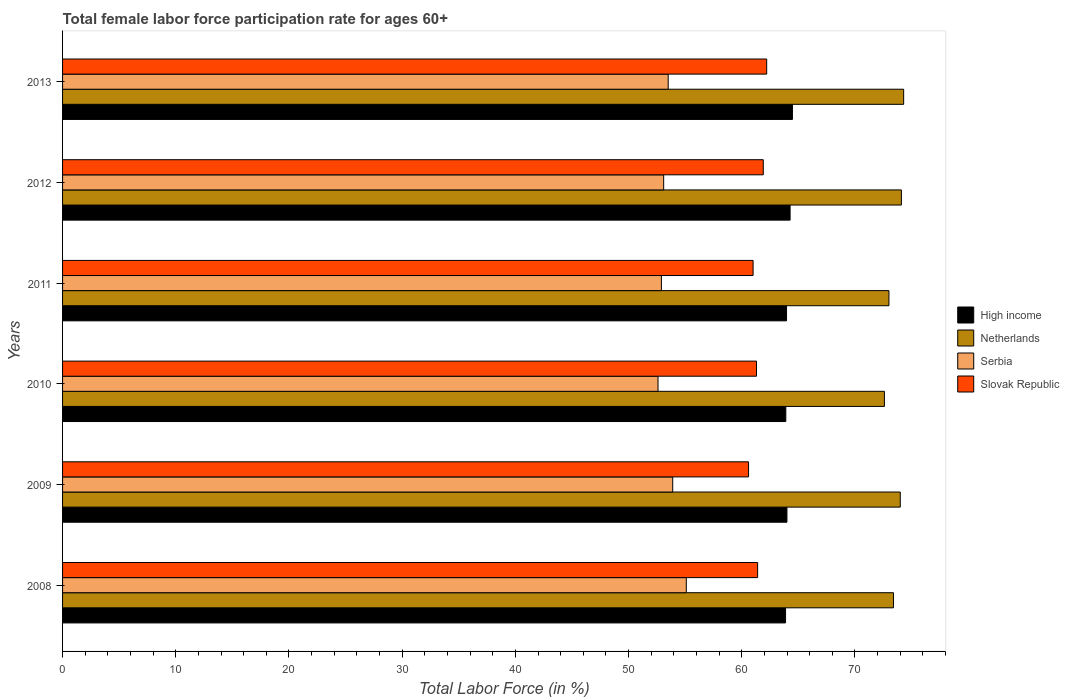What is the label of the 2nd group of bars from the top?
Provide a succinct answer. 2012. What is the female labor force participation rate in Serbia in 2013?
Your answer should be very brief. 53.5. Across all years, what is the maximum female labor force participation rate in High income?
Your response must be concise. 64.47. Across all years, what is the minimum female labor force participation rate in Netherlands?
Your answer should be very brief. 72.6. In which year was the female labor force participation rate in Serbia minimum?
Offer a very short reply. 2010. What is the total female labor force participation rate in Slovak Republic in the graph?
Keep it short and to the point. 368.4. What is the difference between the female labor force participation rate in Slovak Republic in 2008 and that in 2013?
Your answer should be very brief. -0.8. What is the difference between the female labor force participation rate in Netherlands in 2010 and the female labor force participation rate in Slovak Republic in 2008?
Your answer should be compact. 11.2. What is the average female labor force participation rate in Netherlands per year?
Provide a short and direct response. 73.57. In the year 2010, what is the difference between the female labor force participation rate in Slovak Republic and female labor force participation rate in Netherlands?
Provide a succinct answer. -11.3. What is the ratio of the female labor force participation rate in High income in 2010 to that in 2013?
Your answer should be very brief. 0.99. What is the difference between the highest and the second highest female labor force participation rate in High income?
Offer a terse response. 0.21. What is the difference between the highest and the lowest female labor force participation rate in Netherlands?
Ensure brevity in your answer.  1.7. In how many years, is the female labor force participation rate in Slovak Republic greater than the average female labor force participation rate in Slovak Republic taken over all years?
Give a very brief answer. 3. Is it the case that in every year, the sum of the female labor force participation rate in High income and female labor force participation rate in Serbia is greater than the sum of female labor force participation rate in Netherlands and female labor force participation rate in Slovak Republic?
Keep it short and to the point. No. What does the 2nd bar from the top in 2012 represents?
Your response must be concise. Serbia. How many bars are there?
Provide a succinct answer. 24. Are all the bars in the graph horizontal?
Your answer should be very brief. Yes. How many years are there in the graph?
Provide a succinct answer. 6. Are the values on the major ticks of X-axis written in scientific E-notation?
Give a very brief answer. No. Does the graph contain any zero values?
Ensure brevity in your answer.  No. Does the graph contain grids?
Your answer should be very brief. No. Where does the legend appear in the graph?
Your answer should be compact. Center right. How many legend labels are there?
Provide a succinct answer. 4. How are the legend labels stacked?
Provide a succinct answer. Vertical. What is the title of the graph?
Provide a short and direct response. Total female labor force participation rate for ages 60+. Does "Aruba" appear as one of the legend labels in the graph?
Provide a short and direct response. No. What is the label or title of the X-axis?
Give a very brief answer. Total Labor Force (in %). What is the Total Labor Force (in %) in High income in 2008?
Offer a terse response. 63.87. What is the Total Labor Force (in %) of Netherlands in 2008?
Provide a short and direct response. 73.4. What is the Total Labor Force (in %) of Serbia in 2008?
Your response must be concise. 55.1. What is the Total Labor Force (in %) in Slovak Republic in 2008?
Provide a succinct answer. 61.4. What is the Total Labor Force (in %) of High income in 2009?
Your answer should be compact. 63.99. What is the Total Labor Force (in %) of Serbia in 2009?
Give a very brief answer. 53.9. What is the Total Labor Force (in %) of Slovak Republic in 2009?
Your answer should be compact. 60.6. What is the Total Labor Force (in %) of High income in 2010?
Ensure brevity in your answer.  63.89. What is the Total Labor Force (in %) of Netherlands in 2010?
Keep it short and to the point. 72.6. What is the Total Labor Force (in %) of Serbia in 2010?
Your answer should be very brief. 52.6. What is the Total Labor Force (in %) of Slovak Republic in 2010?
Keep it short and to the point. 61.3. What is the Total Labor Force (in %) of High income in 2011?
Provide a short and direct response. 63.95. What is the Total Labor Force (in %) of Serbia in 2011?
Provide a succinct answer. 52.9. What is the Total Labor Force (in %) of Slovak Republic in 2011?
Offer a terse response. 61. What is the Total Labor Force (in %) in High income in 2012?
Your answer should be compact. 64.27. What is the Total Labor Force (in %) in Netherlands in 2012?
Provide a short and direct response. 74.1. What is the Total Labor Force (in %) in Serbia in 2012?
Your answer should be compact. 53.1. What is the Total Labor Force (in %) in Slovak Republic in 2012?
Keep it short and to the point. 61.9. What is the Total Labor Force (in %) in High income in 2013?
Offer a terse response. 64.47. What is the Total Labor Force (in %) of Netherlands in 2013?
Offer a very short reply. 74.3. What is the Total Labor Force (in %) in Serbia in 2013?
Ensure brevity in your answer.  53.5. What is the Total Labor Force (in %) of Slovak Republic in 2013?
Your answer should be compact. 62.2. Across all years, what is the maximum Total Labor Force (in %) in High income?
Offer a very short reply. 64.47. Across all years, what is the maximum Total Labor Force (in %) of Netherlands?
Your answer should be compact. 74.3. Across all years, what is the maximum Total Labor Force (in %) in Serbia?
Offer a very short reply. 55.1. Across all years, what is the maximum Total Labor Force (in %) in Slovak Republic?
Your answer should be compact. 62.2. Across all years, what is the minimum Total Labor Force (in %) in High income?
Offer a terse response. 63.87. Across all years, what is the minimum Total Labor Force (in %) of Netherlands?
Your answer should be very brief. 72.6. Across all years, what is the minimum Total Labor Force (in %) in Serbia?
Provide a succinct answer. 52.6. Across all years, what is the minimum Total Labor Force (in %) of Slovak Republic?
Provide a short and direct response. 60.6. What is the total Total Labor Force (in %) of High income in the graph?
Offer a very short reply. 384.44. What is the total Total Labor Force (in %) in Netherlands in the graph?
Give a very brief answer. 441.4. What is the total Total Labor Force (in %) of Serbia in the graph?
Your answer should be very brief. 321.1. What is the total Total Labor Force (in %) of Slovak Republic in the graph?
Keep it short and to the point. 368.4. What is the difference between the Total Labor Force (in %) in High income in 2008 and that in 2009?
Keep it short and to the point. -0.12. What is the difference between the Total Labor Force (in %) of Netherlands in 2008 and that in 2009?
Keep it short and to the point. -0.6. What is the difference between the Total Labor Force (in %) in High income in 2008 and that in 2010?
Provide a succinct answer. -0.02. What is the difference between the Total Labor Force (in %) of Serbia in 2008 and that in 2010?
Provide a short and direct response. 2.5. What is the difference between the Total Labor Force (in %) in High income in 2008 and that in 2011?
Keep it short and to the point. -0.09. What is the difference between the Total Labor Force (in %) in Netherlands in 2008 and that in 2011?
Your answer should be compact. 0.4. What is the difference between the Total Labor Force (in %) in Serbia in 2008 and that in 2011?
Make the answer very short. 2.2. What is the difference between the Total Labor Force (in %) in Slovak Republic in 2008 and that in 2011?
Your answer should be compact. 0.4. What is the difference between the Total Labor Force (in %) in High income in 2008 and that in 2012?
Keep it short and to the point. -0.4. What is the difference between the Total Labor Force (in %) in Serbia in 2008 and that in 2012?
Make the answer very short. 2. What is the difference between the Total Labor Force (in %) in Slovak Republic in 2008 and that in 2012?
Provide a short and direct response. -0.5. What is the difference between the Total Labor Force (in %) in High income in 2008 and that in 2013?
Your answer should be very brief. -0.61. What is the difference between the Total Labor Force (in %) of Netherlands in 2008 and that in 2013?
Provide a succinct answer. -0.9. What is the difference between the Total Labor Force (in %) of Slovak Republic in 2008 and that in 2013?
Ensure brevity in your answer.  -0.8. What is the difference between the Total Labor Force (in %) in High income in 2009 and that in 2010?
Provide a succinct answer. 0.1. What is the difference between the Total Labor Force (in %) of Netherlands in 2009 and that in 2010?
Give a very brief answer. 1.4. What is the difference between the Total Labor Force (in %) in High income in 2009 and that in 2011?
Ensure brevity in your answer.  0.04. What is the difference between the Total Labor Force (in %) in Netherlands in 2009 and that in 2011?
Provide a succinct answer. 1. What is the difference between the Total Labor Force (in %) in Serbia in 2009 and that in 2011?
Your response must be concise. 1. What is the difference between the Total Labor Force (in %) in Slovak Republic in 2009 and that in 2011?
Ensure brevity in your answer.  -0.4. What is the difference between the Total Labor Force (in %) in High income in 2009 and that in 2012?
Offer a very short reply. -0.28. What is the difference between the Total Labor Force (in %) in Slovak Republic in 2009 and that in 2012?
Your answer should be compact. -1.3. What is the difference between the Total Labor Force (in %) in High income in 2009 and that in 2013?
Give a very brief answer. -0.49. What is the difference between the Total Labor Force (in %) of Slovak Republic in 2009 and that in 2013?
Offer a terse response. -1.6. What is the difference between the Total Labor Force (in %) of High income in 2010 and that in 2011?
Your response must be concise. -0.06. What is the difference between the Total Labor Force (in %) of Serbia in 2010 and that in 2011?
Offer a very short reply. -0.3. What is the difference between the Total Labor Force (in %) of High income in 2010 and that in 2012?
Provide a short and direct response. -0.38. What is the difference between the Total Labor Force (in %) of Serbia in 2010 and that in 2012?
Offer a very short reply. -0.5. What is the difference between the Total Labor Force (in %) in High income in 2010 and that in 2013?
Keep it short and to the point. -0.58. What is the difference between the Total Labor Force (in %) in Netherlands in 2010 and that in 2013?
Offer a very short reply. -1.7. What is the difference between the Total Labor Force (in %) in Slovak Republic in 2010 and that in 2013?
Keep it short and to the point. -0.9. What is the difference between the Total Labor Force (in %) in High income in 2011 and that in 2012?
Your answer should be very brief. -0.31. What is the difference between the Total Labor Force (in %) in Netherlands in 2011 and that in 2012?
Provide a succinct answer. -1.1. What is the difference between the Total Labor Force (in %) in Slovak Republic in 2011 and that in 2012?
Provide a succinct answer. -0.9. What is the difference between the Total Labor Force (in %) of High income in 2011 and that in 2013?
Your answer should be compact. -0.52. What is the difference between the Total Labor Force (in %) in Netherlands in 2011 and that in 2013?
Keep it short and to the point. -1.3. What is the difference between the Total Labor Force (in %) of High income in 2012 and that in 2013?
Offer a very short reply. -0.21. What is the difference between the Total Labor Force (in %) in Netherlands in 2012 and that in 2013?
Your answer should be very brief. -0.2. What is the difference between the Total Labor Force (in %) in Slovak Republic in 2012 and that in 2013?
Your answer should be very brief. -0.3. What is the difference between the Total Labor Force (in %) in High income in 2008 and the Total Labor Force (in %) in Netherlands in 2009?
Your answer should be compact. -10.13. What is the difference between the Total Labor Force (in %) in High income in 2008 and the Total Labor Force (in %) in Serbia in 2009?
Your answer should be very brief. 9.97. What is the difference between the Total Labor Force (in %) in High income in 2008 and the Total Labor Force (in %) in Slovak Republic in 2009?
Offer a terse response. 3.27. What is the difference between the Total Labor Force (in %) in Netherlands in 2008 and the Total Labor Force (in %) in Serbia in 2009?
Offer a terse response. 19.5. What is the difference between the Total Labor Force (in %) of High income in 2008 and the Total Labor Force (in %) of Netherlands in 2010?
Make the answer very short. -8.73. What is the difference between the Total Labor Force (in %) of High income in 2008 and the Total Labor Force (in %) of Serbia in 2010?
Your answer should be very brief. 11.27. What is the difference between the Total Labor Force (in %) in High income in 2008 and the Total Labor Force (in %) in Slovak Republic in 2010?
Your response must be concise. 2.57. What is the difference between the Total Labor Force (in %) in Netherlands in 2008 and the Total Labor Force (in %) in Serbia in 2010?
Make the answer very short. 20.8. What is the difference between the Total Labor Force (in %) of High income in 2008 and the Total Labor Force (in %) of Netherlands in 2011?
Make the answer very short. -9.13. What is the difference between the Total Labor Force (in %) of High income in 2008 and the Total Labor Force (in %) of Serbia in 2011?
Give a very brief answer. 10.97. What is the difference between the Total Labor Force (in %) in High income in 2008 and the Total Labor Force (in %) in Slovak Republic in 2011?
Provide a short and direct response. 2.87. What is the difference between the Total Labor Force (in %) in Netherlands in 2008 and the Total Labor Force (in %) in Serbia in 2011?
Your response must be concise. 20.5. What is the difference between the Total Labor Force (in %) in Netherlands in 2008 and the Total Labor Force (in %) in Slovak Republic in 2011?
Your answer should be compact. 12.4. What is the difference between the Total Labor Force (in %) of High income in 2008 and the Total Labor Force (in %) of Netherlands in 2012?
Ensure brevity in your answer.  -10.23. What is the difference between the Total Labor Force (in %) of High income in 2008 and the Total Labor Force (in %) of Serbia in 2012?
Your answer should be very brief. 10.77. What is the difference between the Total Labor Force (in %) in High income in 2008 and the Total Labor Force (in %) in Slovak Republic in 2012?
Give a very brief answer. 1.97. What is the difference between the Total Labor Force (in %) in Netherlands in 2008 and the Total Labor Force (in %) in Serbia in 2012?
Give a very brief answer. 20.3. What is the difference between the Total Labor Force (in %) of High income in 2008 and the Total Labor Force (in %) of Netherlands in 2013?
Offer a very short reply. -10.43. What is the difference between the Total Labor Force (in %) in High income in 2008 and the Total Labor Force (in %) in Serbia in 2013?
Your response must be concise. 10.37. What is the difference between the Total Labor Force (in %) of High income in 2008 and the Total Labor Force (in %) of Slovak Republic in 2013?
Keep it short and to the point. 1.67. What is the difference between the Total Labor Force (in %) of Netherlands in 2008 and the Total Labor Force (in %) of Slovak Republic in 2013?
Provide a short and direct response. 11.2. What is the difference between the Total Labor Force (in %) in High income in 2009 and the Total Labor Force (in %) in Netherlands in 2010?
Your response must be concise. -8.61. What is the difference between the Total Labor Force (in %) in High income in 2009 and the Total Labor Force (in %) in Serbia in 2010?
Your answer should be very brief. 11.39. What is the difference between the Total Labor Force (in %) of High income in 2009 and the Total Labor Force (in %) of Slovak Republic in 2010?
Offer a terse response. 2.69. What is the difference between the Total Labor Force (in %) of Netherlands in 2009 and the Total Labor Force (in %) of Serbia in 2010?
Keep it short and to the point. 21.4. What is the difference between the Total Labor Force (in %) in Netherlands in 2009 and the Total Labor Force (in %) in Slovak Republic in 2010?
Your answer should be compact. 12.7. What is the difference between the Total Labor Force (in %) of Serbia in 2009 and the Total Labor Force (in %) of Slovak Republic in 2010?
Make the answer very short. -7.4. What is the difference between the Total Labor Force (in %) in High income in 2009 and the Total Labor Force (in %) in Netherlands in 2011?
Give a very brief answer. -9.01. What is the difference between the Total Labor Force (in %) in High income in 2009 and the Total Labor Force (in %) in Serbia in 2011?
Ensure brevity in your answer.  11.09. What is the difference between the Total Labor Force (in %) of High income in 2009 and the Total Labor Force (in %) of Slovak Republic in 2011?
Provide a succinct answer. 2.99. What is the difference between the Total Labor Force (in %) in Netherlands in 2009 and the Total Labor Force (in %) in Serbia in 2011?
Your answer should be very brief. 21.1. What is the difference between the Total Labor Force (in %) of Netherlands in 2009 and the Total Labor Force (in %) of Slovak Republic in 2011?
Your response must be concise. 13. What is the difference between the Total Labor Force (in %) in Serbia in 2009 and the Total Labor Force (in %) in Slovak Republic in 2011?
Ensure brevity in your answer.  -7.1. What is the difference between the Total Labor Force (in %) of High income in 2009 and the Total Labor Force (in %) of Netherlands in 2012?
Provide a short and direct response. -10.11. What is the difference between the Total Labor Force (in %) of High income in 2009 and the Total Labor Force (in %) of Serbia in 2012?
Make the answer very short. 10.89. What is the difference between the Total Labor Force (in %) of High income in 2009 and the Total Labor Force (in %) of Slovak Republic in 2012?
Offer a very short reply. 2.09. What is the difference between the Total Labor Force (in %) of Netherlands in 2009 and the Total Labor Force (in %) of Serbia in 2012?
Give a very brief answer. 20.9. What is the difference between the Total Labor Force (in %) in Netherlands in 2009 and the Total Labor Force (in %) in Slovak Republic in 2012?
Your answer should be very brief. 12.1. What is the difference between the Total Labor Force (in %) of Serbia in 2009 and the Total Labor Force (in %) of Slovak Republic in 2012?
Provide a succinct answer. -8. What is the difference between the Total Labor Force (in %) in High income in 2009 and the Total Labor Force (in %) in Netherlands in 2013?
Ensure brevity in your answer.  -10.31. What is the difference between the Total Labor Force (in %) in High income in 2009 and the Total Labor Force (in %) in Serbia in 2013?
Offer a very short reply. 10.49. What is the difference between the Total Labor Force (in %) in High income in 2009 and the Total Labor Force (in %) in Slovak Republic in 2013?
Give a very brief answer. 1.79. What is the difference between the Total Labor Force (in %) of Netherlands in 2009 and the Total Labor Force (in %) of Serbia in 2013?
Ensure brevity in your answer.  20.5. What is the difference between the Total Labor Force (in %) of Serbia in 2009 and the Total Labor Force (in %) of Slovak Republic in 2013?
Provide a succinct answer. -8.3. What is the difference between the Total Labor Force (in %) in High income in 2010 and the Total Labor Force (in %) in Netherlands in 2011?
Your response must be concise. -9.11. What is the difference between the Total Labor Force (in %) of High income in 2010 and the Total Labor Force (in %) of Serbia in 2011?
Your answer should be very brief. 10.99. What is the difference between the Total Labor Force (in %) of High income in 2010 and the Total Labor Force (in %) of Slovak Republic in 2011?
Ensure brevity in your answer.  2.89. What is the difference between the Total Labor Force (in %) in Netherlands in 2010 and the Total Labor Force (in %) in Slovak Republic in 2011?
Make the answer very short. 11.6. What is the difference between the Total Labor Force (in %) in High income in 2010 and the Total Labor Force (in %) in Netherlands in 2012?
Your response must be concise. -10.21. What is the difference between the Total Labor Force (in %) of High income in 2010 and the Total Labor Force (in %) of Serbia in 2012?
Offer a terse response. 10.79. What is the difference between the Total Labor Force (in %) in High income in 2010 and the Total Labor Force (in %) in Slovak Republic in 2012?
Make the answer very short. 1.99. What is the difference between the Total Labor Force (in %) of Netherlands in 2010 and the Total Labor Force (in %) of Slovak Republic in 2012?
Keep it short and to the point. 10.7. What is the difference between the Total Labor Force (in %) of Serbia in 2010 and the Total Labor Force (in %) of Slovak Republic in 2012?
Ensure brevity in your answer.  -9.3. What is the difference between the Total Labor Force (in %) of High income in 2010 and the Total Labor Force (in %) of Netherlands in 2013?
Give a very brief answer. -10.41. What is the difference between the Total Labor Force (in %) in High income in 2010 and the Total Labor Force (in %) in Serbia in 2013?
Make the answer very short. 10.39. What is the difference between the Total Labor Force (in %) of High income in 2010 and the Total Labor Force (in %) of Slovak Republic in 2013?
Offer a terse response. 1.69. What is the difference between the Total Labor Force (in %) of Netherlands in 2010 and the Total Labor Force (in %) of Slovak Republic in 2013?
Your answer should be compact. 10.4. What is the difference between the Total Labor Force (in %) of Serbia in 2010 and the Total Labor Force (in %) of Slovak Republic in 2013?
Offer a terse response. -9.6. What is the difference between the Total Labor Force (in %) in High income in 2011 and the Total Labor Force (in %) in Netherlands in 2012?
Ensure brevity in your answer.  -10.15. What is the difference between the Total Labor Force (in %) of High income in 2011 and the Total Labor Force (in %) of Serbia in 2012?
Offer a very short reply. 10.85. What is the difference between the Total Labor Force (in %) of High income in 2011 and the Total Labor Force (in %) of Slovak Republic in 2012?
Make the answer very short. 2.05. What is the difference between the Total Labor Force (in %) in Serbia in 2011 and the Total Labor Force (in %) in Slovak Republic in 2012?
Your answer should be compact. -9. What is the difference between the Total Labor Force (in %) in High income in 2011 and the Total Labor Force (in %) in Netherlands in 2013?
Give a very brief answer. -10.35. What is the difference between the Total Labor Force (in %) of High income in 2011 and the Total Labor Force (in %) of Serbia in 2013?
Your response must be concise. 10.45. What is the difference between the Total Labor Force (in %) in High income in 2011 and the Total Labor Force (in %) in Slovak Republic in 2013?
Keep it short and to the point. 1.75. What is the difference between the Total Labor Force (in %) of Netherlands in 2011 and the Total Labor Force (in %) of Slovak Republic in 2013?
Offer a very short reply. 10.8. What is the difference between the Total Labor Force (in %) in High income in 2012 and the Total Labor Force (in %) in Netherlands in 2013?
Your answer should be very brief. -10.03. What is the difference between the Total Labor Force (in %) of High income in 2012 and the Total Labor Force (in %) of Serbia in 2013?
Keep it short and to the point. 10.77. What is the difference between the Total Labor Force (in %) in High income in 2012 and the Total Labor Force (in %) in Slovak Republic in 2013?
Offer a very short reply. 2.07. What is the difference between the Total Labor Force (in %) in Netherlands in 2012 and the Total Labor Force (in %) in Serbia in 2013?
Offer a very short reply. 20.6. What is the difference between the Total Labor Force (in %) of Netherlands in 2012 and the Total Labor Force (in %) of Slovak Republic in 2013?
Offer a very short reply. 11.9. What is the average Total Labor Force (in %) of High income per year?
Offer a terse response. 64.07. What is the average Total Labor Force (in %) of Netherlands per year?
Offer a terse response. 73.57. What is the average Total Labor Force (in %) of Serbia per year?
Your response must be concise. 53.52. What is the average Total Labor Force (in %) in Slovak Republic per year?
Keep it short and to the point. 61.4. In the year 2008, what is the difference between the Total Labor Force (in %) in High income and Total Labor Force (in %) in Netherlands?
Your response must be concise. -9.53. In the year 2008, what is the difference between the Total Labor Force (in %) of High income and Total Labor Force (in %) of Serbia?
Make the answer very short. 8.77. In the year 2008, what is the difference between the Total Labor Force (in %) in High income and Total Labor Force (in %) in Slovak Republic?
Provide a short and direct response. 2.47. In the year 2008, what is the difference between the Total Labor Force (in %) of Serbia and Total Labor Force (in %) of Slovak Republic?
Ensure brevity in your answer.  -6.3. In the year 2009, what is the difference between the Total Labor Force (in %) of High income and Total Labor Force (in %) of Netherlands?
Your response must be concise. -10.01. In the year 2009, what is the difference between the Total Labor Force (in %) in High income and Total Labor Force (in %) in Serbia?
Your response must be concise. 10.09. In the year 2009, what is the difference between the Total Labor Force (in %) of High income and Total Labor Force (in %) of Slovak Republic?
Offer a terse response. 3.39. In the year 2009, what is the difference between the Total Labor Force (in %) of Netherlands and Total Labor Force (in %) of Serbia?
Your answer should be very brief. 20.1. In the year 2009, what is the difference between the Total Labor Force (in %) in Netherlands and Total Labor Force (in %) in Slovak Republic?
Ensure brevity in your answer.  13.4. In the year 2010, what is the difference between the Total Labor Force (in %) of High income and Total Labor Force (in %) of Netherlands?
Offer a terse response. -8.71. In the year 2010, what is the difference between the Total Labor Force (in %) in High income and Total Labor Force (in %) in Serbia?
Your answer should be compact. 11.29. In the year 2010, what is the difference between the Total Labor Force (in %) of High income and Total Labor Force (in %) of Slovak Republic?
Your answer should be very brief. 2.59. In the year 2010, what is the difference between the Total Labor Force (in %) of Netherlands and Total Labor Force (in %) of Slovak Republic?
Ensure brevity in your answer.  11.3. In the year 2010, what is the difference between the Total Labor Force (in %) of Serbia and Total Labor Force (in %) of Slovak Republic?
Your answer should be compact. -8.7. In the year 2011, what is the difference between the Total Labor Force (in %) in High income and Total Labor Force (in %) in Netherlands?
Offer a terse response. -9.05. In the year 2011, what is the difference between the Total Labor Force (in %) in High income and Total Labor Force (in %) in Serbia?
Your answer should be very brief. 11.05. In the year 2011, what is the difference between the Total Labor Force (in %) in High income and Total Labor Force (in %) in Slovak Republic?
Offer a very short reply. 2.95. In the year 2011, what is the difference between the Total Labor Force (in %) of Netherlands and Total Labor Force (in %) of Serbia?
Your answer should be compact. 20.1. In the year 2011, what is the difference between the Total Labor Force (in %) of Netherlands and Total Labor Force (in %) of Slovak Republic?
Your answer should be very brief. 12. In the year 2012, what is the difference between the Total Labor Force (in %) of High income and Total Labor Force (in %) of Netherlands?
Offer a terse response. -9.83. In the year 2012, what is the difference between the Total Labor Force (in %) in High income and Total Labor Force (in %) in Serbia?
Give a very brief answer. 11.17. In the year 2012, what is the difference between the Total Labor Force (in %) in High income and Total Labor Force (in %) in Slovak Republic?
Provide a succinct answer. 2.37. In the year 2012, what is the difference between the Total Labor Force (in %) of Netherlands and Total Labor Force (in %) of Slovak Republic?
Provide a succinct answer. 12.2. In the year 2012, what is the difference between the Total Labor Force (in %) in Serbia and Total Labor Force (in %) in Slovak Republic?
Your answer should be very brief. -8.8. In the year 2013, what is the difference between the Total Labor Force (in %) in High income and Total Labor Force (in %) in Netherlands?
Provide a succinct answer. -9.83. In the year 2013, what is the difference between the Total Labor Force (in %) of High income and Total Labor Force (in %) of Serbia?
Offer a very short reply. 10.97. In the year 2013, what is the difference between the Total Labor Force (in %) of High income and Total Labor Force (in %) of Slovak Republic?
Give a very brief answer. 2.27. In the year 2013, what is the difference between the Total Labor Force (in %) in Netherlands and Total Labor Force (in %) in Serbia?
Your response must be concise. 20.8. What is the ratio of the Total Labor Force (in %) of High income in 2008 to that in 2009?
Make the answer very short. 1. What is the ratio of the Total Labor Force (in %) in Serbia in 2008 to that in 2009?
Your response must be concise. 1.02. What is the ratio of the Total Labor Force (in %) in Slovak Republic in 2008 to that in 2009?
Your response must be concise. 1.01. What is the ratio of the Total Labor Force (in %) in High income in 2008 to that in 2010?
Ensure brevity in your answer.  1. What is the ratio of the Total Labor Force (in %) of Netherlands in 2008 to that in 2010?
Your answer should be very brief. 1.01. What is the ratio of the Total Labor Force (in %) in Serbia in 2008 to that in 2010?
Provide a succinct answer. 1.05. What is the ratio of the Total Labor Force (in %) in Slovak Republic in 2008 to that in 2010?
Offer a terse response. 1. What is the ratio of the Total Labor Force (in %) in Netherlands in 2008 to that in 2011?
Provide a short and direct response. 1.01. What is the ratio of the Total Labor Force (in %) in Serbia in 2008 to that in 2011?
Make the answer very short. 1.04. What is the ratio of the Total Labor Force (in %) of Slovak Republic in 2008 to that in 2011?
Offer a terse response. 1.01. What is the ratio of the Total Labor Force (in %) in High income in 2008 to that in 2012?
Your answer should be very brief. 0.99. What is the ratio of the Total Labor Force (in %) of Netherlands in 2008 to that in 2012?
Offer a terse response. 0.99. What is the ratio of the Total Labor Force (in %) of Serbia in 2008 to that in 2012?
Provide a succinct answer. 1.04. What is the ratio of the Total Labor Force (in %) of Slovak Republic in 2008 to that in 2012?
Offer a terse response. 0.99. What is the ratio of the Total Labor Force (in %) of High income in 2008 to that in 2013?
Give a very brief answer. 0.99. What is the ratio of the Total Labor Force (in %) of Netherlands in 2008 to that in 2013?
Offer a terse response. 0.99. What is the ratio of the Total Labor Force (in %) in Serbia in 2008 to that in 2013?
Offer a very short reply. 1.03. What is the ratio of the Total Labor Force (in %) of Slovak Republic in 2008 to that in 2013?
Make the answer very short. 0.99. What is the ratio of the Total Labor Force (in %) of Netherlands in 2009 to that in 2010?
Offer a terse response. 1.02. What is the ratio of the Total Labor Force (in %) in Serbia in 2009 to that in 2010?
Provide a succinct answer. 1.02. What is the ratio of the Total Labor Force (in %) of Netherlands in 2009 to that in 2011?
Provide a succinct answer. 1.01. What is the ratio of the Total Labor Force (in %) in Serbia in 2009 to that in 2011?
Offer a terse response. 1.02. What is the ratio of the Total Labor Force (in %) of High income in 2009 to that in 2012?
Give a very brief answer. 1. What is the ratio of the Total Labor Force (in %) of Netherlands in 2009 to that in 2012?
Keep it short and to the point. 1. What is the ratio of the Total Labor Force (in %) in Serbia in 2009 to that in 2012?
Offer a terse response. 1.02. What is the ratio of the Total Labor Force (in %) of High income in 2009 to that in 2013?
Provide a succinct answer. 0.99. What is the ratio of the Total Labor Force (in %) in Serbia in 2009 to that in 2013?
Ensure brevity in your answer.  1.01. What is the ratio of the Total Labor Force (in %) of Slovak Republic in 2009 to that in 2013?
Your answer should be very brief. 0.97. What is the ratio of the Total Labor Force (in %) of High income in 2010 to that in 2011?
Your answer should be very brief. 1. What is the ratio of the Total Labor Force (in %) of Netherlands in 2010 to that in 2011?
Offer a terse response. 0.99. What is the ratio of the Total Labor Force (in %) in Serbia in 2010 to that in 2011?
Keep it short and to the point. 0.99. What is the ratio of the Total Labor Force (in %) in Slovak Republic in 2010 to that in 2011?
Provide a succinct answer. 1. What is the ratio of the Total Labor Force (in %) in Netherlands in 2010 to that in 2012?
Offer a very short reply. 0.98. What is the ratio of the Total Labor Force (in %) of Serbia in 2010 to that in 2012?
Give a very brief answer. 0.99. What is the ratio of the Total Labor Force (in %) in Slovak Republic in 2010 to that in 2012?
Give a very brief answer. 0.99. What is the ratio of the Total Labor Force (in %) of High income in 2010 to that in 2013?
Provide a short and direct response. 0.99. What is the ratio of the Total Labor Force (in %) in Netherlands in 2010 to that in 2013?
Ensure brevity in your answer.  0.98. What is the ratio of the Total Labor Force (in %) in Serbia in 2010 to that in 2013?
Your answer should be very brief. 0.98. What is the ratio of the Total Labor Force (in %) in Slovak Republic in 2010 to that in 2013?
Make the answer very short. 0.99. What is the ratio of the Total Labor Force (in %) in Netherlands in 2011 to that in 2012?
Offer a very short reply. 0.99. What is the ratio of the Total Labor Force (in %) in Slovak Republic in 2011 to that in 2012?
Your answer should be compact. 0.99. What is the ratio of the Total Labor Force (in %) of High income in 2011 to that in 2013?
Your answer should be very brief. 0.99. What is the ratio of the Total Labor Force (in %) of Netherlands in 2011 to that in 2013?
Ensure brevity in your answer.  0.98. What is the ratio of the Total Labor Force (in %) in Serbia in 2011 to that in 2013?
Ensure brevity in your answer.  0.99. What is the ratio of the Total Labor Force (in %) in Slovak Republic in 2011 to that in 2013?
Ensure brevity in your answer.  0.98. What is the ratio of the Total Labor Force (in %) in High income in 2012 to that in 2013?
Keep it short and to the point. 1. What is the ratio of the Total Labor Force (in %) of Serbia in 2012 to that in 2013?
Offer a very short reply. 0.99. What is the difference between the highest and the second highest Total Labor Force (in %) of High income?
Keep it short and to the point. 0.21. What is the difference between the highest and the second highest Total Labor Force (in %) of Serbia?
Offer a terse response. 1.2. What is the difference between the highest and the second highest Total Labor Force (in %) in Slovak Republic?
Your answer should be compact. 0.3. What is the difference between the highest and the lowest Total Labor Force (in %) of High income?
Keep it short and to the point. 0.61. What is the difference between the highest and the lowest Total Labor Force (in %) of Netherlands?
Provide a succinct answer. 1.7. What is the difference between the highest and the lowest Total Labor Force (in %) of Serbia?
Your answer should be very brief. 2.5. What is the difference between the highest and the lowest Total Labor Force (in %) in Slovak Republic?
Provide a succinct answer. 1.6. 